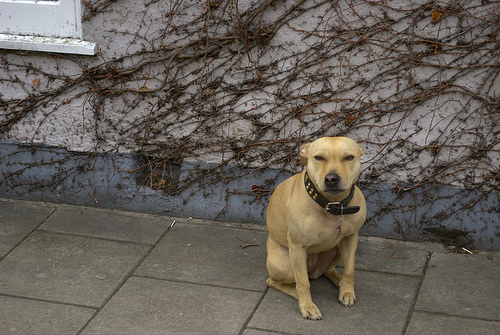Can you describe the setting where the dog is located? The dog is situated on a paved sidewalk against a light-colored wall with climbing dried vines. It gives off the impression of a serene, possibly residential area. 